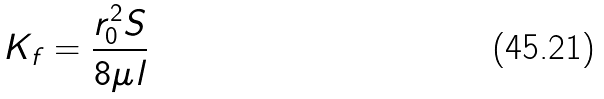Convert formula to latex. <formula><loc_0><loc_0><loc_500><loc_500>K _ { f } = \frac { r _ { 0 } ^ { 2 } S } { 8 \mu l }</formula> 